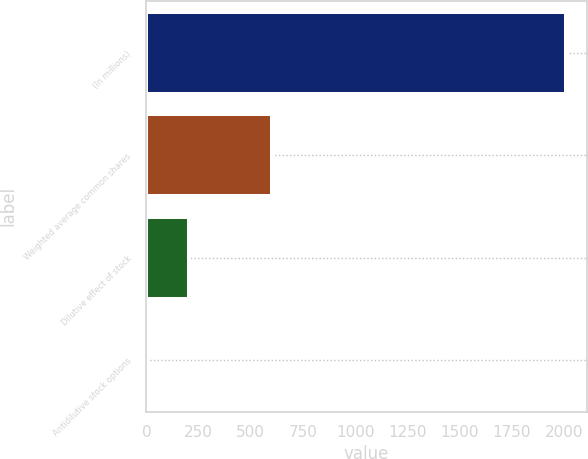Convert chart. <chart><loc_0><loc_0><loc_500><loc_500><bar_chart><fcel>(In millions)<fcel>Weighted average common shares<fcel>Dilutive effect of stock<fcel>Antidilutive stock options<nl><fcel>2010<fcel>603.84<fcel>202.08<fcel>1.2<nl></chart> 